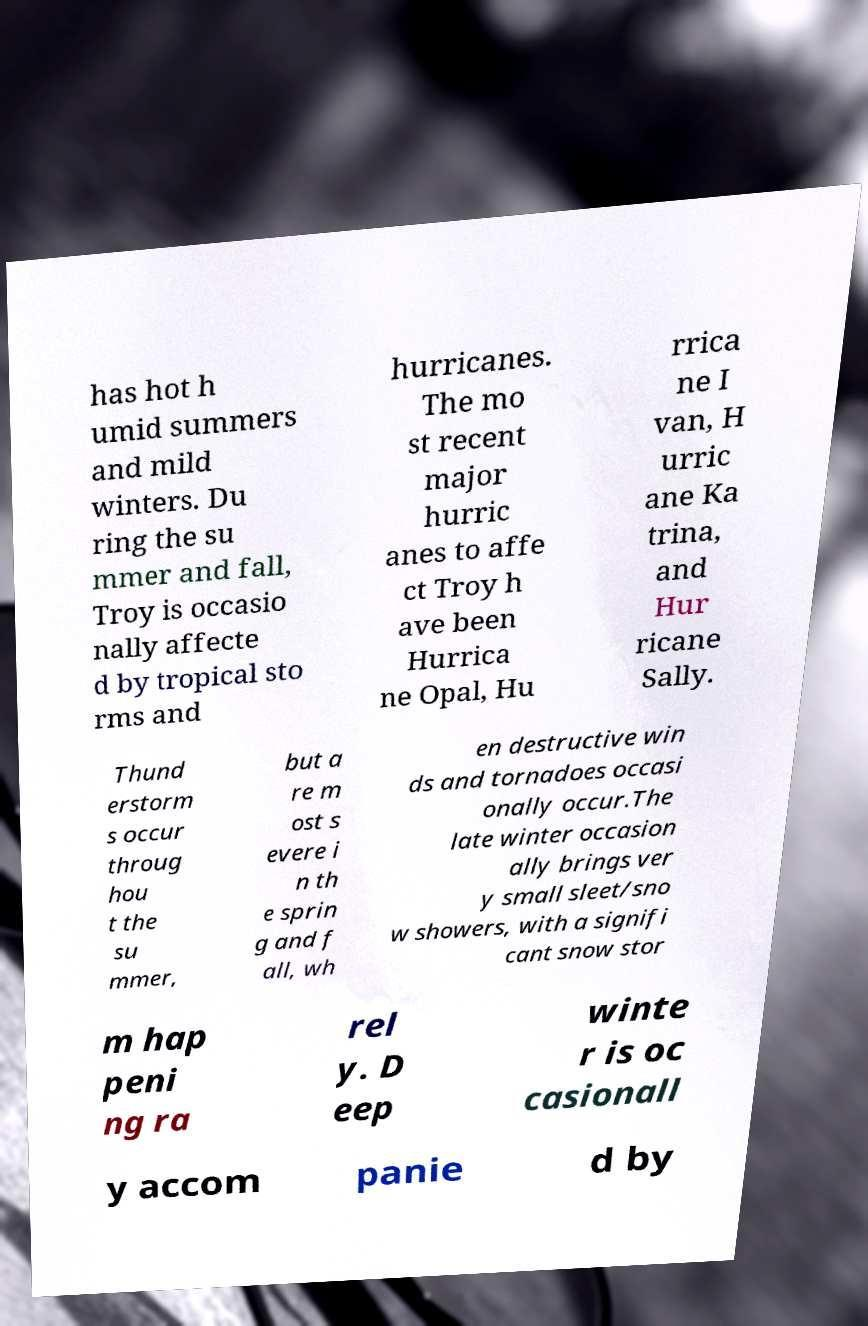Please read and relay the text visible in this image. What does it say? has hot h umid summers and mild winters. Du ring the su mmer and fall, Troy is occasio nally affecte d by tropical sto rms and hurricanes. The mo st recent major hurric anes to affe ct Troy h ave been Hurrica ne Opal, Hu rrica ne I van, H urric ane Ka trina, and Hur ricane Sally. Thund erstorm s occur throug hou t the su mmer, but a re m ost s evere i n th e sprin g and f all, wh en destructive win ds and tornadoes occasi onally occur.The late winter occasion ally brings ver y small sleet/sno w showers, with a signifi cant snow stor m hap peni ng ra rel y. D eep winte r is oc casionall y accom panie d by 